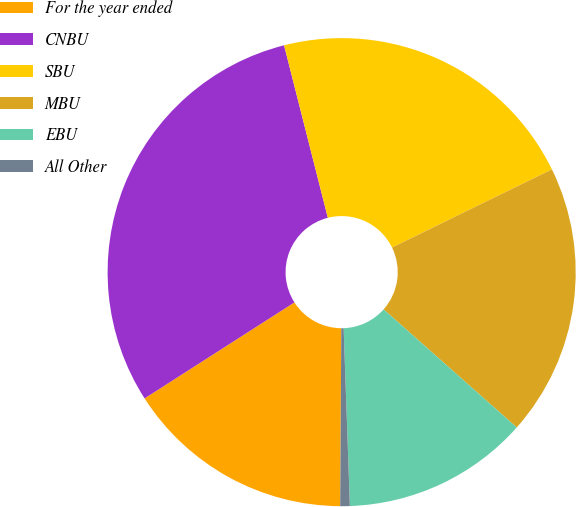Convert chart to OTSL. <chart><loc_0><loc_0><loc_500><loc_500><pie_chart><fcel>For the year ended<fcel>CNBU<fcel>SBU<fcel>MBU<fcel>EBU<fcel>All Other<nl><fcel>15.83%<fcel>30.11%<fcel>21.72%<fcel>18.78%<fcel>12.89%<fcel>0.66%<nl></chart> 